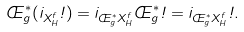Convert formula to latex. <formula><loc_0><loc_0><loc_500><loc_500>\phi _ { g } ^ { * } ( i _ { X ^ { f } _ { H } } \omega ) = i _ { \phi ^ { * } _ { g } X ^ { f } _ { H } } \phi ^ { * } _ { g } \omega = i _ { \phi ^ { * } _ { g } X ^ { f } _ { H } } \omega .</formula> 